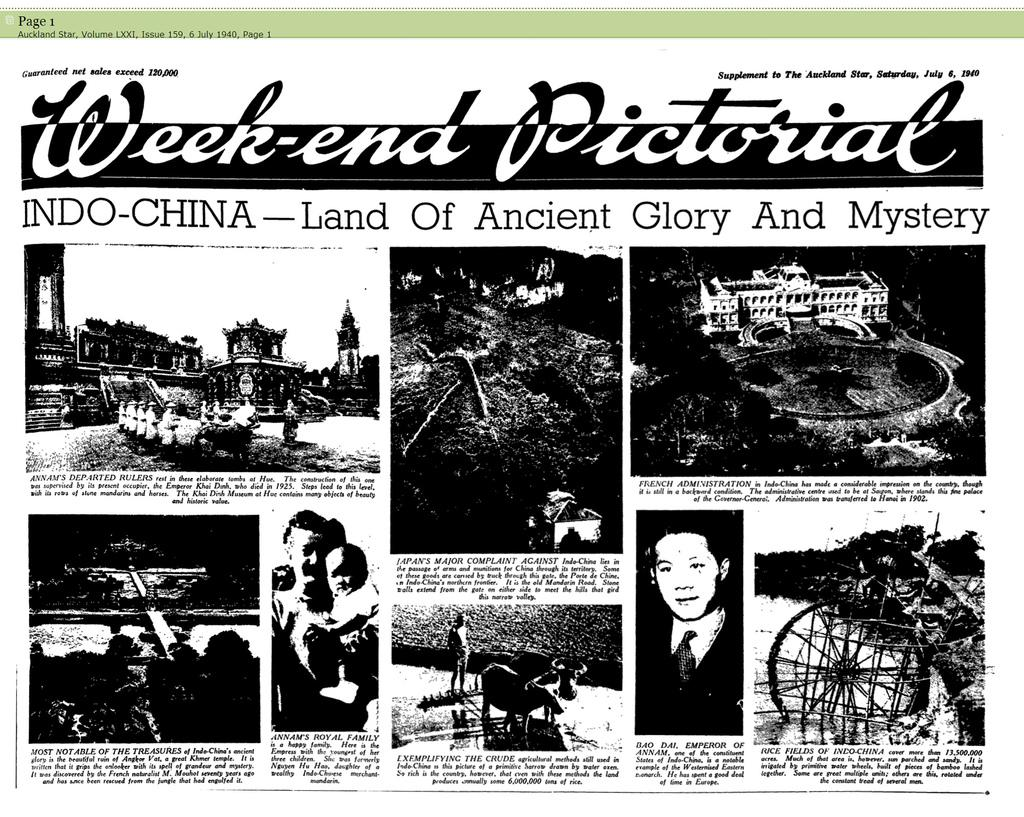How many people are in the image? There is a group of people in the image. What type of structures can be seen in the image? There are buildings in the image. What type of terrain is present in the image? There is sand and mud in the image. What type of transportation is visible in the image? There is a vehicle in the image. What type of environment is depicted in the image? There is water in the image. What type of living organisms are present in the image? There are animals in the image. What type of objects can be seen in the image? There are some objects in the image. What song is being sung by the person in the image? There is no person singing a song in the image. What type of animal is being ridden by the person in the image? There is no person riding an animal in the image. 